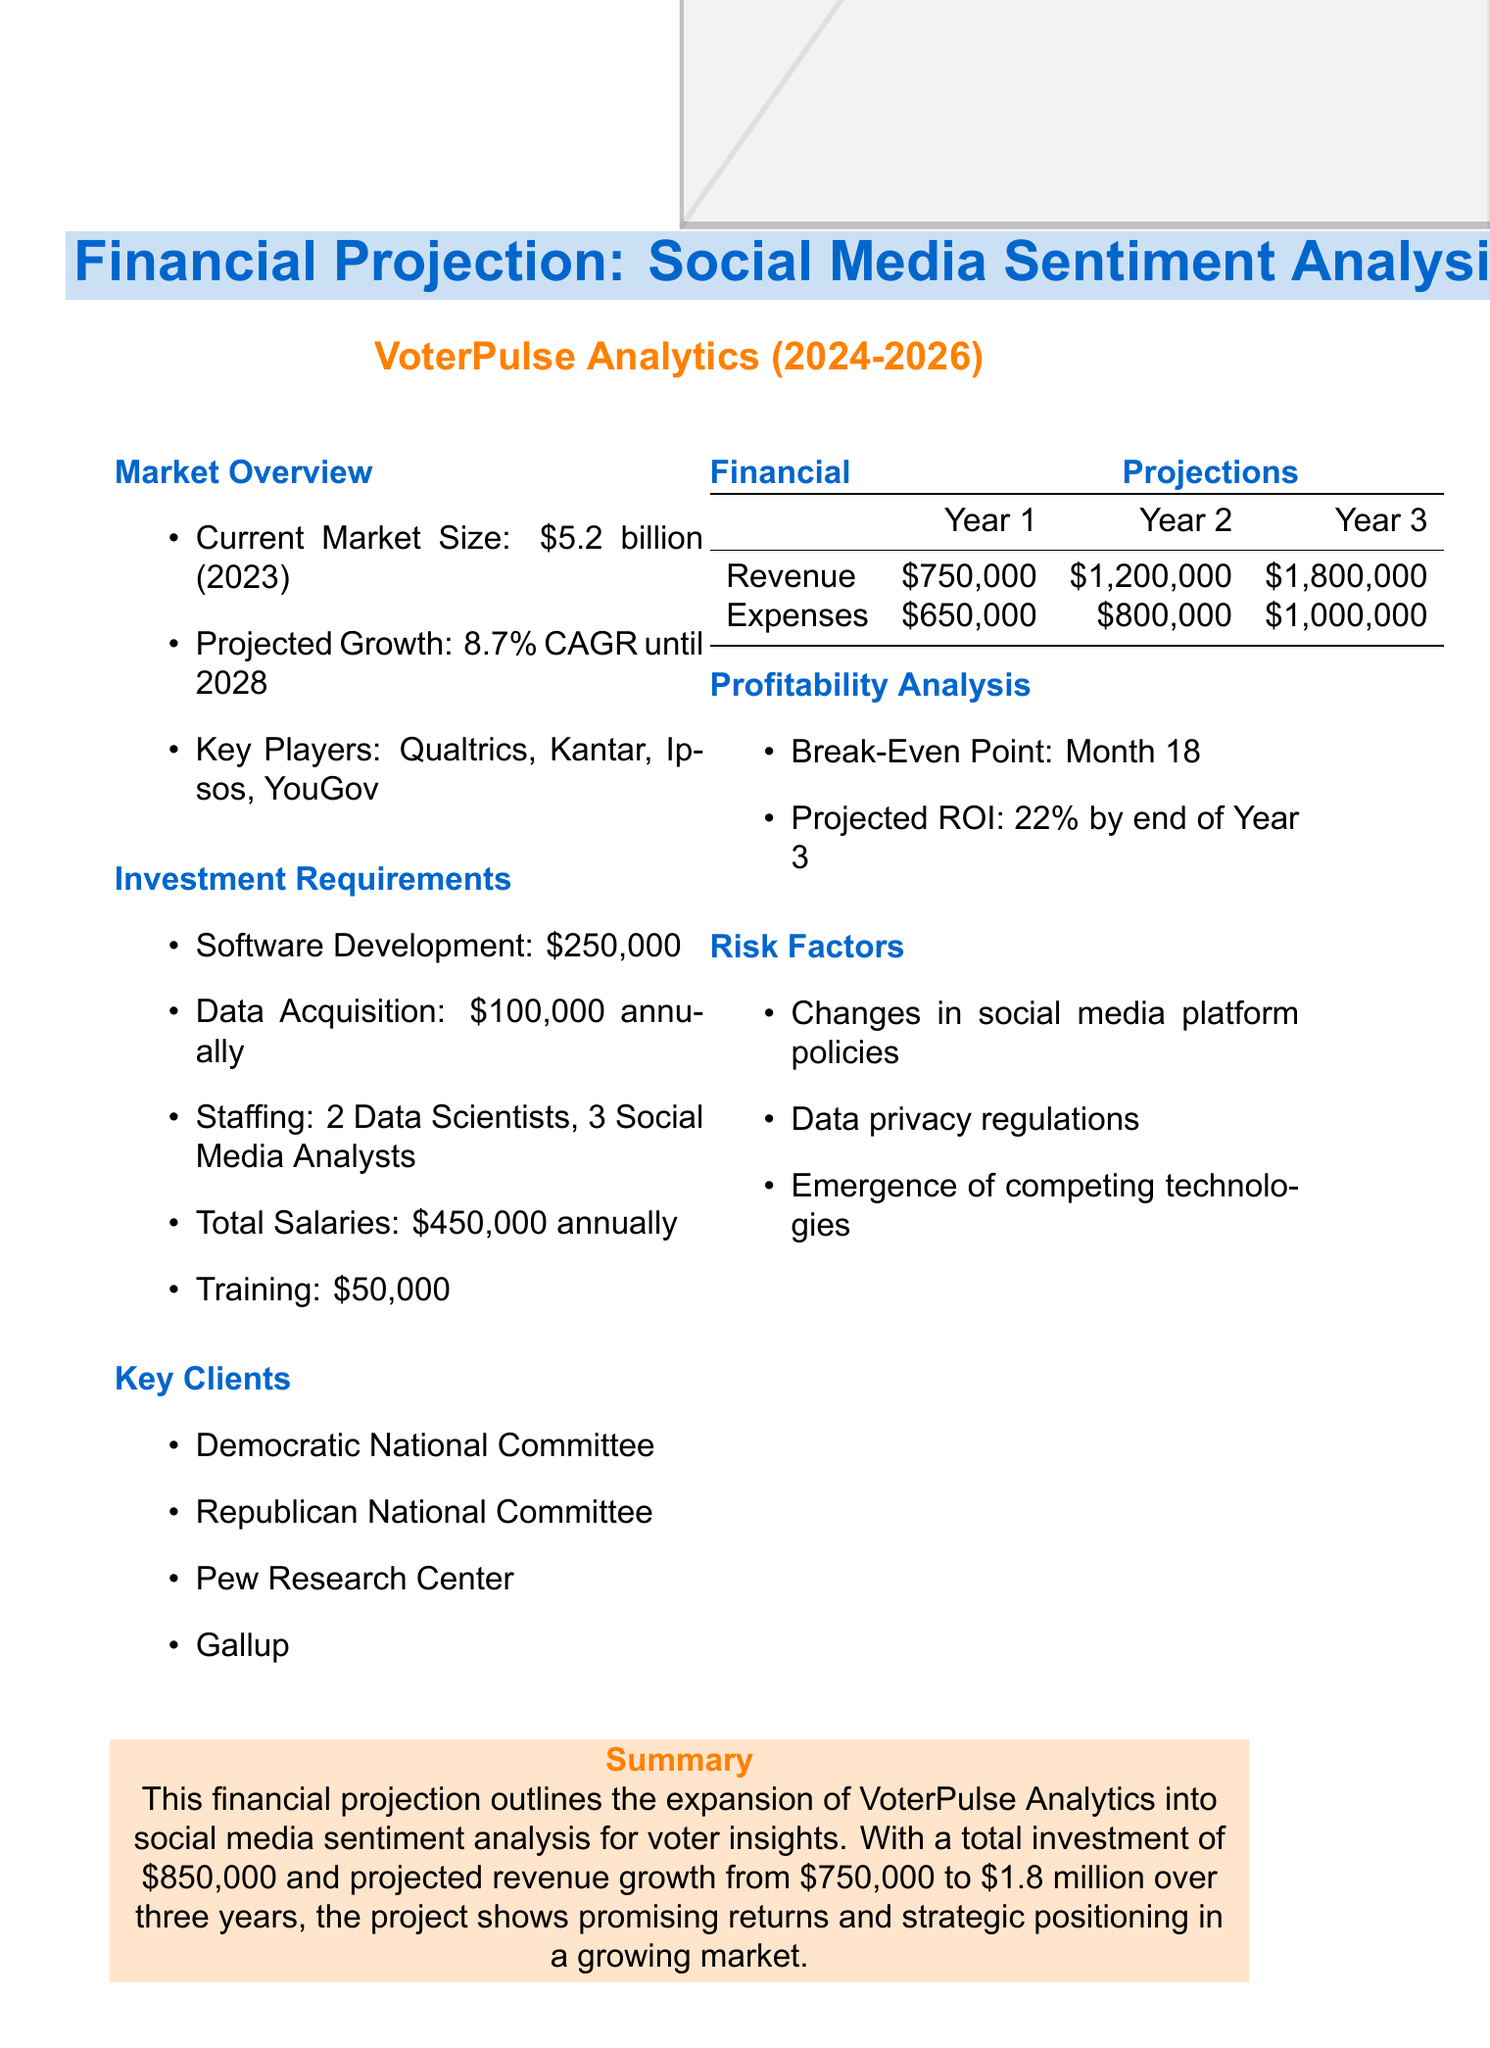What is the project duration? The project duration is specified as between the years 2024 to 2026.
Answer: 3 years (2024-2026) What is the current market size? The document states the current market size as of 2023.
Answer: $5.2 billion (2023) What is the projected revenue for Year 3? The revenue projection for Year 3 is mentioned in the financial projections section.
Answer: $1,800,000 What are the key clients listed? The document includes a specific list of key clients in the market research sector.
Answer: Democratic National Committee, Republican National Committee, Pew Research Center, Gallup What is the break-even point? The break-even point is highlighted in the profitability analysis section of the report.
Answer: Month 18 What is the total investment required? Total investment can be calculated from the investment requirements section, including software, data acquisition, and staffing.
Answer: $850,000 Which key players are identified in the market? The document lists specific companies that are key players in the market research industry.
Answer: Qualtrics, Kantar, Ipsos, YouGov What is the projected ROI by the end of Year 3? The ROI projection is indicated in the profitability analysis of the report.
Answer: 22% by end of Year 3 What annual data acquisition cost is projected? The investment requirements section specifies the annual cost for data acquisition.
Answer: $100,000 annually 